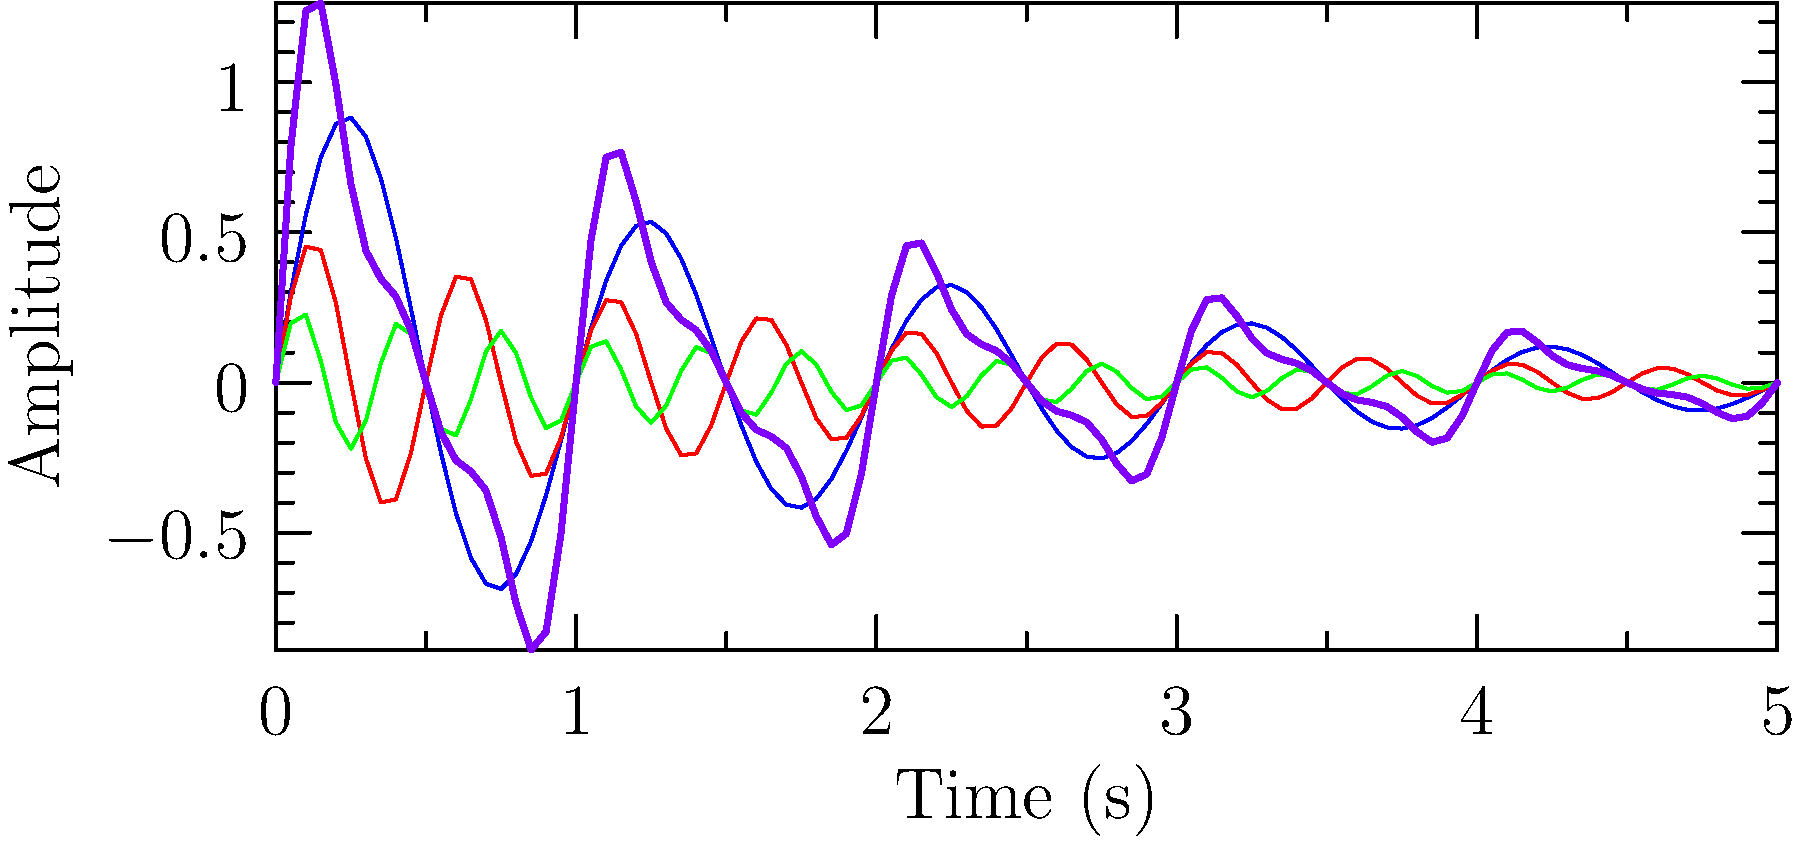In the graph above, which represents the harmonics of a violin string, what is the relationship between the frequency of the 2nd harmonic (red) and the fundamental frequency (blue)? To determine the relationship between the frequency of the 2nd harmonic and the fundamental frequency, we need to analyze the graph:

1. The fundamental frequency (blue line) completes one full cycle in approximately 1 second.
2. The 2nd harmonic (red line) completes two full cycles in the same time period.

To calculate the ratio:
1. Frequency of fundamental = 1 cycle / 1 second = 1 Hz
2. Frequency of 2nd harmonic = 2 cycles / 1 second = 2 Hz

The relationship can be expressed as a ratio:
$$ \frac{\text{Frequency of 2nd Harmonic}}{\text{Frequency of Fundamental}} = \frac{2 \text{ Hz}}{1 \text{ Hz}} = 2:1 $$

This relationship is consistent with the harmonic series in string instruments, where the frequency of the nth harmonic is n times the fundamental frequency.
Answer: 2:1 ratio 